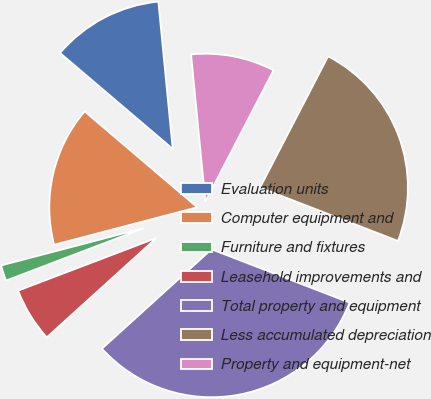Convert chart. <chart><loc_0><loc_0><loc_500><loc_500><pie_chart><fcel>Evaluation units<fcel>Computer equipment and<fcel>Furniture and fixtures<fcel>Leasehold improvements and<fcel>Total property and equipment<fcel>Less accumulated depreciation<fcel>Property and equipment-net<nl><fcel>12.23%<fcel>15.3%<fcel>1.71%<fcel>5.93%<fcel>32.41%<fcel>23.25%<fcel>9.16%<nl></chart> 